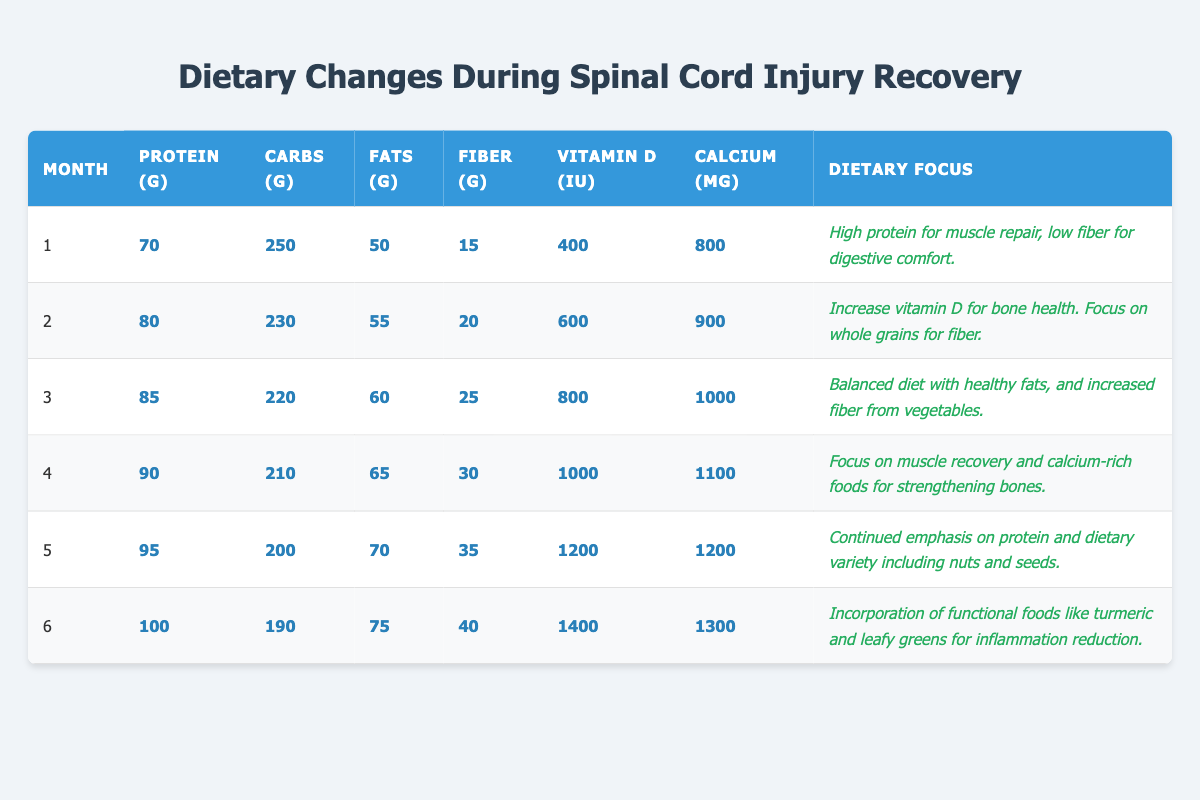What is the protein intake in month 3? The table shows the nutrient intake for each month. In the row for month 3, the protein intake is listed as 85 grams.
Answer: 85 grams What month has the highest fiber intake? To determine which month has the highest fiber intake, I will look through the fiber values across all months. Month 6 has the highest fiber intake at 40 grams.
Answer: Month 6 How much calcium was consumed in month 5 compared to month 1? In month 5, the calcium intake is 1200 mg, and in month 1, it is 800 mg. The difference is 1200 - 800 = 400 mg.
Answer: 400 mg What is the total protein intake across months 1 to 3? I will sum the protein intakes for the first three months: Month 1 is 70 g, Month 2 is 80 g, and Month 3 is 85 g. The total is 70 + 80 + 85 = 235 g.
Answer: 235 grams Was there an increase in vitamin D intake from month 2 to month 4? Check the vitamin D intake for month 2, which is 600 IU, and month 4, which is 1000 IU. Since 1000 IU > 600 IU, there was indeed an increase.
Answer: Yes What is the average carbohydrate intake from months 4 to 6? First, I'll find the carbohydrate intakes for months 4, 5, and 6, which are 210 g, 200 g, and 190 g respectively. To find the average, I sum these values (210 + 200 + 190 = 600) and divide by 3: 600 / 3 = 200 g.
Answer: 200 grams How does the fat intake trend change throughout the six months? Observing the fat intake values, Month 1 starts with 50 g and gradually increases to 75 g in Month 6. This indicates a consistent upward trend in fat intake across the recovery period.
Answer: It increases consistently In which month did the dietary focus shift to include functional foods? The dietary focus for including functional foods like turmeric and leafy greens started in month 6.
Answer: Month 6 What was the total increase of vitamin D from month 1 to month 5? The vitamin D in month 1 is 400 IU, and in month 5 it is 1200 IU. The total increase is calculated as 1200 - 400 = 800 IU.
Answer: 800 IU What are the benefits of the dietary focuses mentioned from month 2 to month 4? Month 2 focuses on vitamin D for bone health, while month 3 introduces a balanced diet with healthy fats. Month 4 emphasizes muscle recovery and calcium-rich foods. The benefits include improved bone density and enhanced muscle repair.
Answer: Improved bone density and muscle repair 